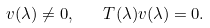<formula> <loc_0><loc_0><loc_500><loc_500>v ( \lambda ) \neq 0 , \quad T ( \lambda ) v ( \lambda ) = 0 .</formula> 